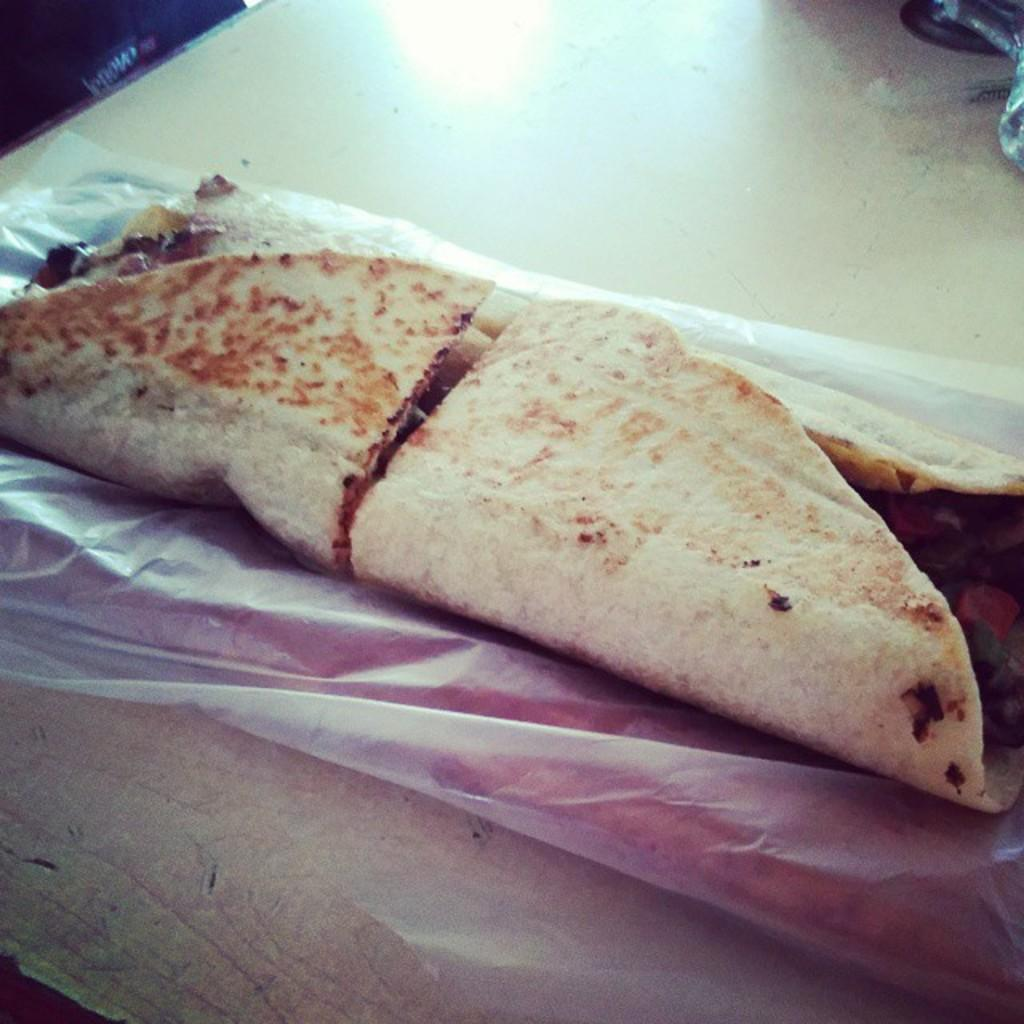What is the main subject of the image? There is a food item in the image. What is the food item placed on? The food item is on a white color paper. What is the color of the surface beneath the white paper? The white paper is on a cream color surface. How would you describe the color of the food item? The food item has brown and cream colors. What type of quiver is visible on the stage in the image? There is no quiver or stage present in the image; it features a food item on a white paper on a cream color surface. 